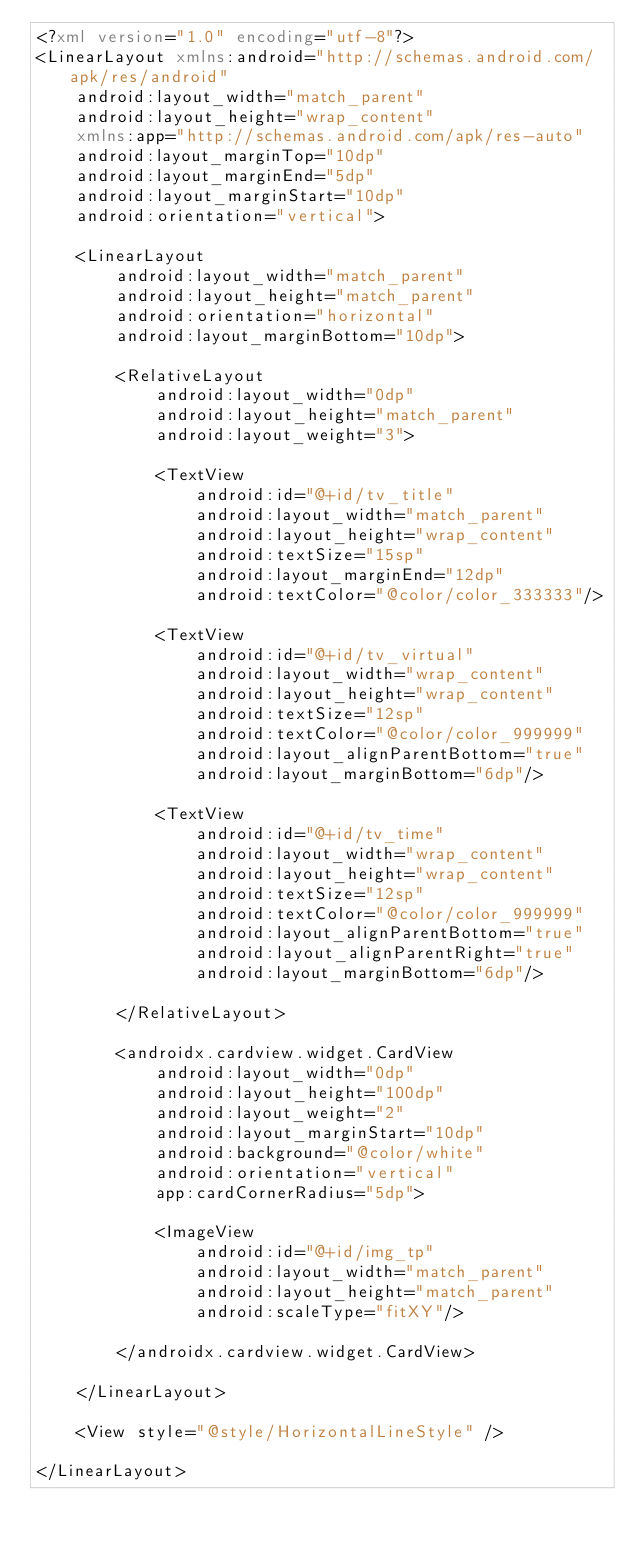Convert code to text. <code><loc_0><loc_0><loc_500><loc_500><_XML_><?xml version="1.0" encoding="utf-8"?>
<LinearLayout xmlns:android="http://schemas.android.com/apk/res/android"
    android:layout_width="match_parent"
    android:layout_height="wrap_content"
    xmlns:app="http://schemas.android.com/apk/res-auto"
    android:layout_marginTop="10dp"
    android:layout_marginEnd="5dp"
    android:layout_marginStart="10dp"
    android:orientation="vertical">

    <LinearLayout
        android:layout_width="match_parent"
        android:layout_height="match_parent"
        android:orientation="horizontal"
        android:layout_marginBottom="10dp">

        <RelativeLayout
            android:layout_width="0dp"
            android:layout_height="match_parent"
            android:layout_weight="3">

            <TextView
                android:id="@+id/tv_title"
                android:layout_width="match_parent"
                android:layout_height="wrap_content"
                android:textSize="15sp"
                android:layout_marginEnd="12dp"
                android:textColor="@color/color_333333"/>

            <TextView
                android:id="@+id/tv_virtual"
                android:layout_width="wrap_content"
                android:layout_height="wrap_content"
                android:textSize="12sp"
                android:textColor="@color/color_999999"
                android:layout_alignParentBottom="true"
                android:layout_marginBottom="6dp"/>

            <TextView
                android:id="@+id/tv_time"
                android:layout_width="wrap_content"
                android:layout_height="wrap_content"
                android:textSize="12sp"
                android:textColor="@color/color_999999"
                android:layout_alignParentBottom="true"
                android:layout_alignParentRight="true"
                android:layout_marginBottom="6dp"/>

        </RelativeLayout>

        <androidx.cardview.widget.CardView
            android:layout_width="0dp"
            android:layout_height="100dp"
            android:layout_weight="2"
            android:layout_marginStart="10dp"
            android:background="@color/white"
            android:orientation="vertical"
            app:cardCornerRadius="5dp">

            <ImageView
                android:id="@+id/img_tp"
                android:layout_width="match_parent"
                android:layout_height="match_parent"
                android:scaleType="fitXY"/>

        </androidx.cardview.widget.CardView>

    </LinearLayout>

    <View style="@style/HorizontalLineStyle" />

</LinearLayout></code> 